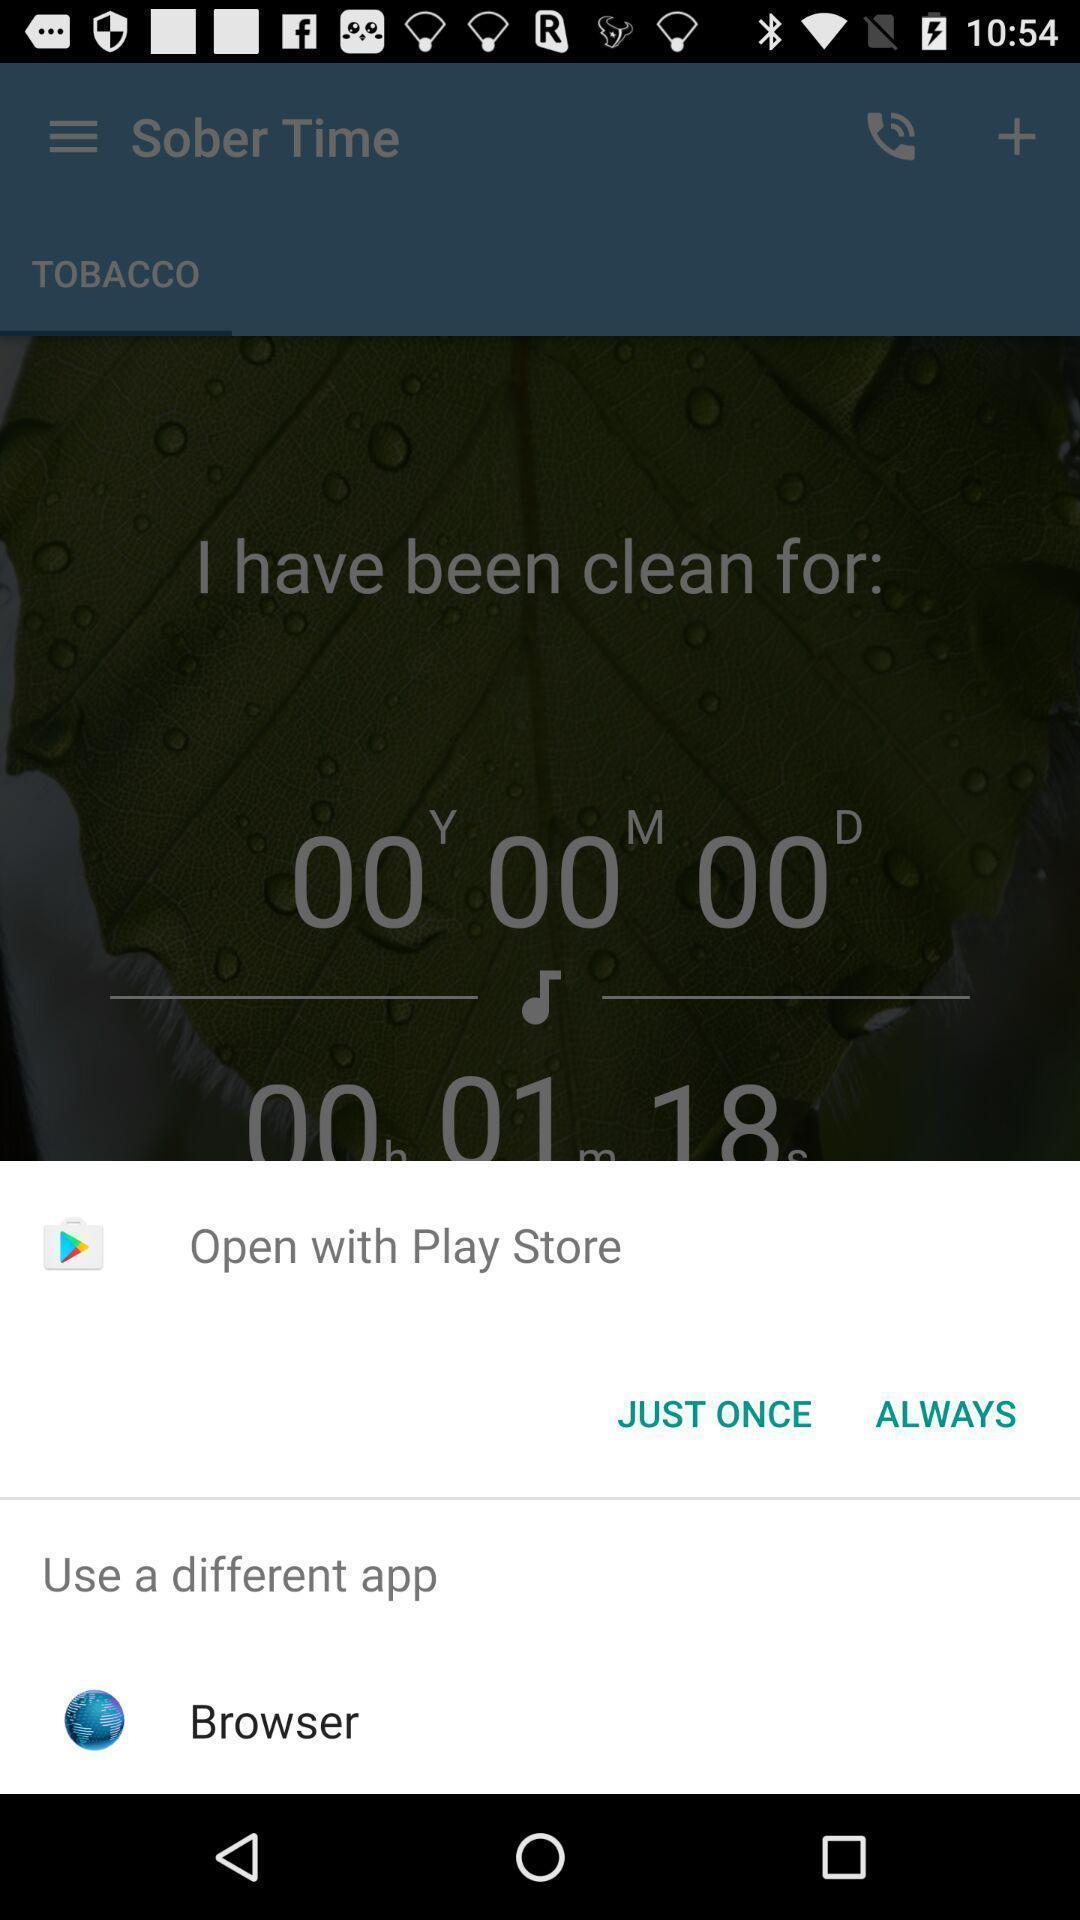What is the overall content of this screenshot? Screen showing multiple options to open with. 